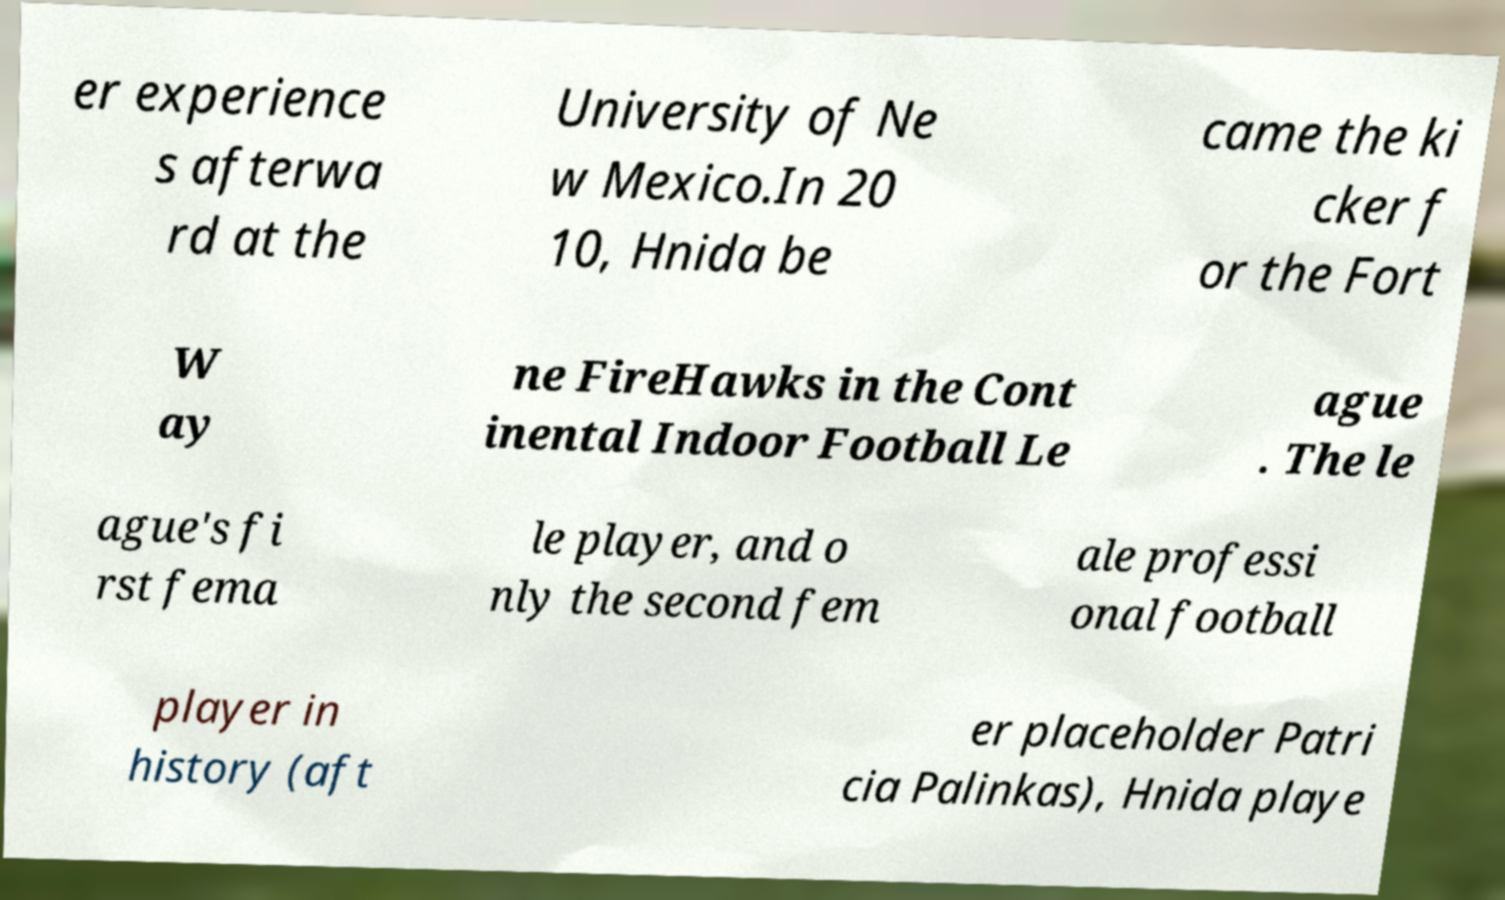For documentation purposes, I need the text within this image transcribed. Could you provide that? er experience s afterwa rd at the University of Ne w Mexico.In 20 10, Hnida be came the ki cker f or the Fort W ay ne FireHawks in the Cont inental Indoor Football Le ague . The le ague's fi rst fema le player, and o nly the second fem ale professi onal football player in history (aft er placeholder Patri cia Palinkas), Hnida playe 